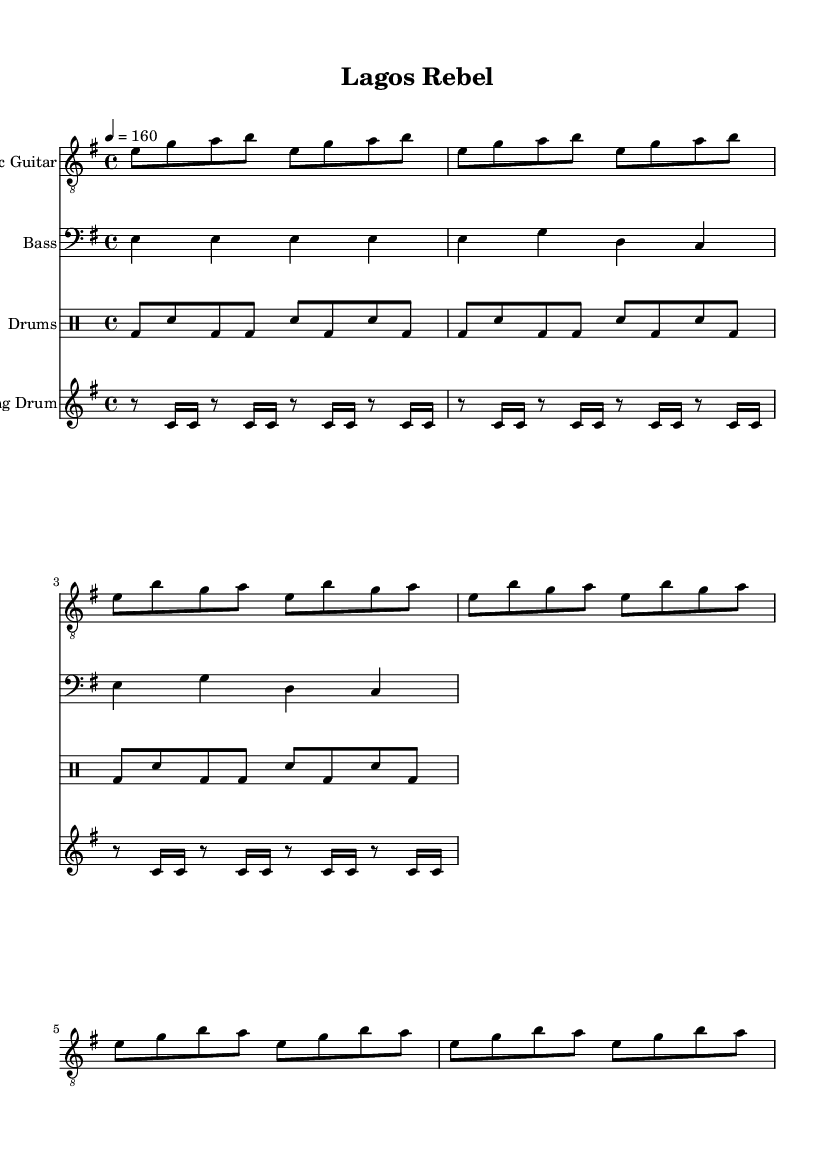What is the key signature of this music? The key signature is E minor, which has one sharp (F#). E minor is indicated at the beginning of the score.
Answer: E minor What is the time signature of the piece? The time signature is 4/4, which means there are four beats in a measure, and the quarter note gets one beat. This is specified at the start of the sheet music.
Answer: 4/4 What is the tempo marking for the music? The tempo marking is 160 beats per minute, shown as "4 = 160". This indicates the speed at which the piece should be played.
Answer: 160 Which instruments are featured in the score? The score features an electric guitar, bass, drums, and talking drum, as indicated by the instrument names at the beginning of each staff.
Answer: Electric Guitar, Bass, Drums, Talking Drum How many measures are in the verse section? The verse section consists of 4 measures, as counted from the notation where each measure is separated by the vertical lines.
Answer: 4 What kind of beat is indicated in the drums part? The drums part indicates a basic punk beat, characterized by a kick drum (bd) and snare (sn) pattern that reflects the energetic style typical of punk music.
Answer: Punk beat What unique rhythmic element is included in the music? The unique rhythmic element is the syncopated pattern played by the talking drum, which emphasizes off-beats and adds a traditional Nigerian musical influence to the punk fusion.
Answer: Syncopated pattern 